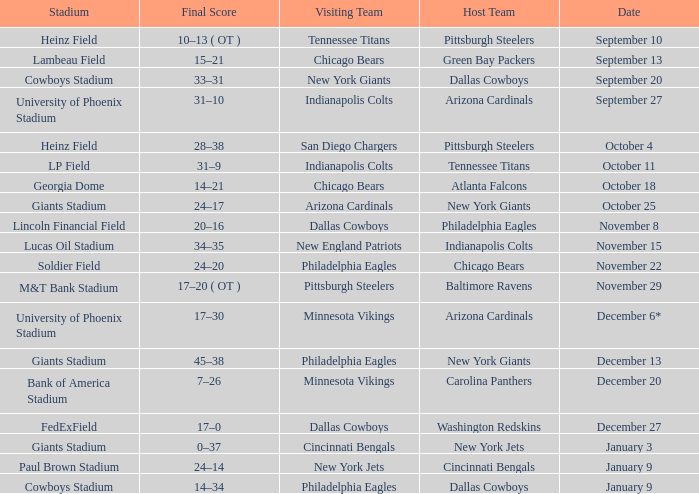Tell me the visiting team for october 4 San Diego Chargers. 